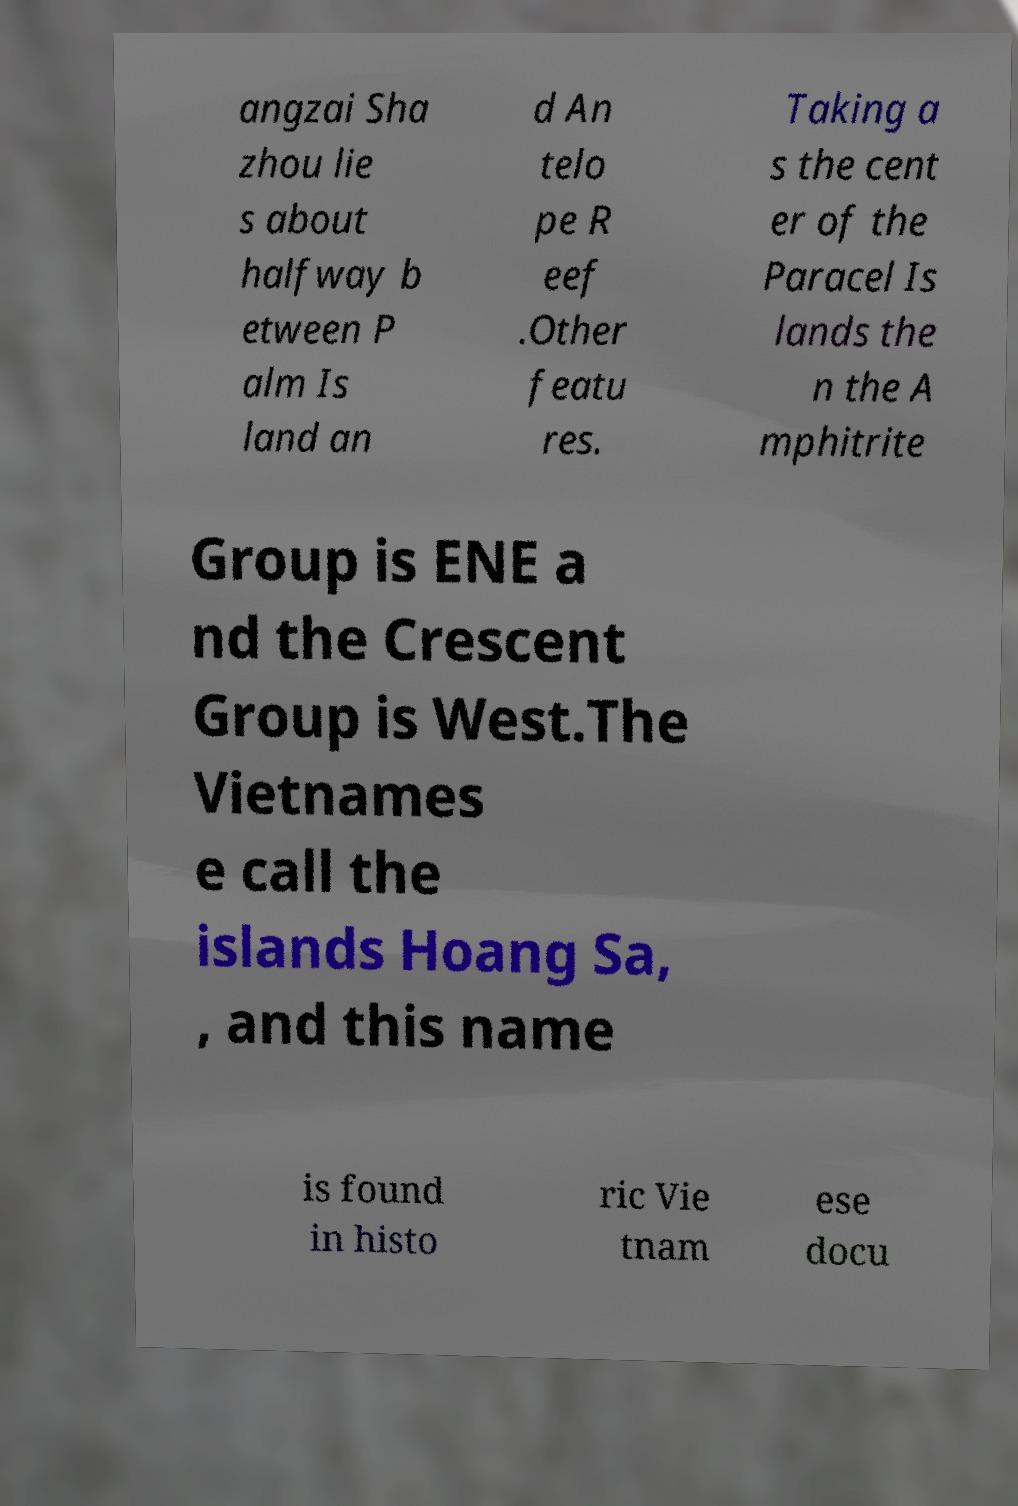I need the written content from this picture converted into text. Can you do that? angzai Sha zhou lie s about halfway b etween P alm Is land an d An telo pe R eef .Other featu res. Taking a s the cent er of the Paracel Is lands the n the A mphitrite Group is ENE a nd the Crescent Group is West.The Vietnames e call the islands Hoang Sa, , and this name is found in histo ric Vie tnam ese docu 